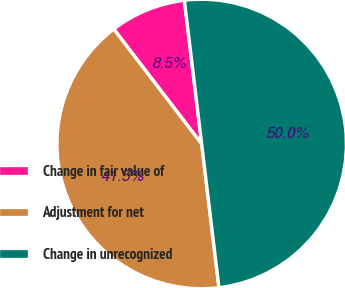<chart> <loc_0><loc_0><loc_500><loc_500><pie_chart><fcel>Change in fair value of<fcel>Adjustment for net<fcel>Change in unrecognized<nl><fcel>8.49%<fcel>41.51%<fcel>50.0%<nl></chart> 